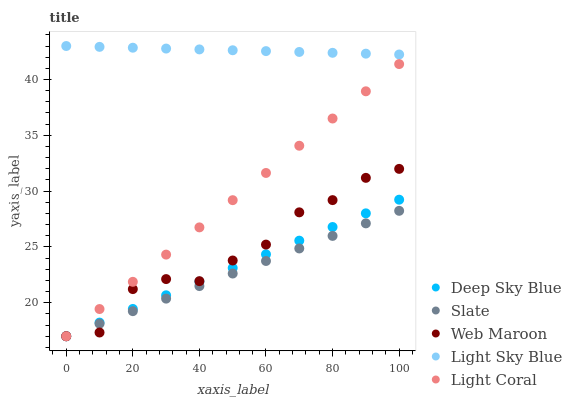Does Slate have the minimum area under the curve?
Answer yes or no. Yes. Does Light Sky Blue have the maximum area under the curve?
Answer yes or no. Yes. Does Light Sky Blue have the minimum area under the curve?
Answer yes or no. No. Does Slate have the maximum area under the curve?
Answer yes or no. No. Is Slate the smoothest?
Answer yes or no. Yes. Is Web Maroon the roughest?
Answer yes or no. Yes. Is Light Sky Blue the smoothest?
Answer yes or no. No. Is Light Sky Blue the roughest?
Answer yes or no. No. Does Light Coral have the lowest value?
Answer yes or no. Yes. Does Light Sky Blue have the lowest value?
Answer yes or no. No. Does Light Sky Blue have the highest value?
Answer yes or no. Yes. Does Slate have the highest value?
Answer yes or no. No. Is Web Maroon less than Light Sky Blue?
Answer yes or no. Yes. Is Light Sky Blue greater than Web Maroon?
Answer yes or no. Yes. Does Slate intersect Web Maroon?
Answer yes or no. Yes. Is Slate less than Web Maroon?
Answer yes or no. No. Is Slate greater than Web Maroon?
Answer yes or no. No. Does Web Maroon intersect Light Sky Blue?
Answer yes or no. No. 